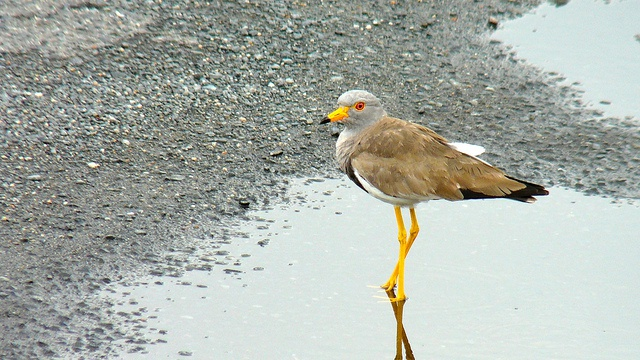Describe the objects in this image and their specific colors. I can see a bird in gray, tan, olive, ivory, and darkgray tones in this image. 